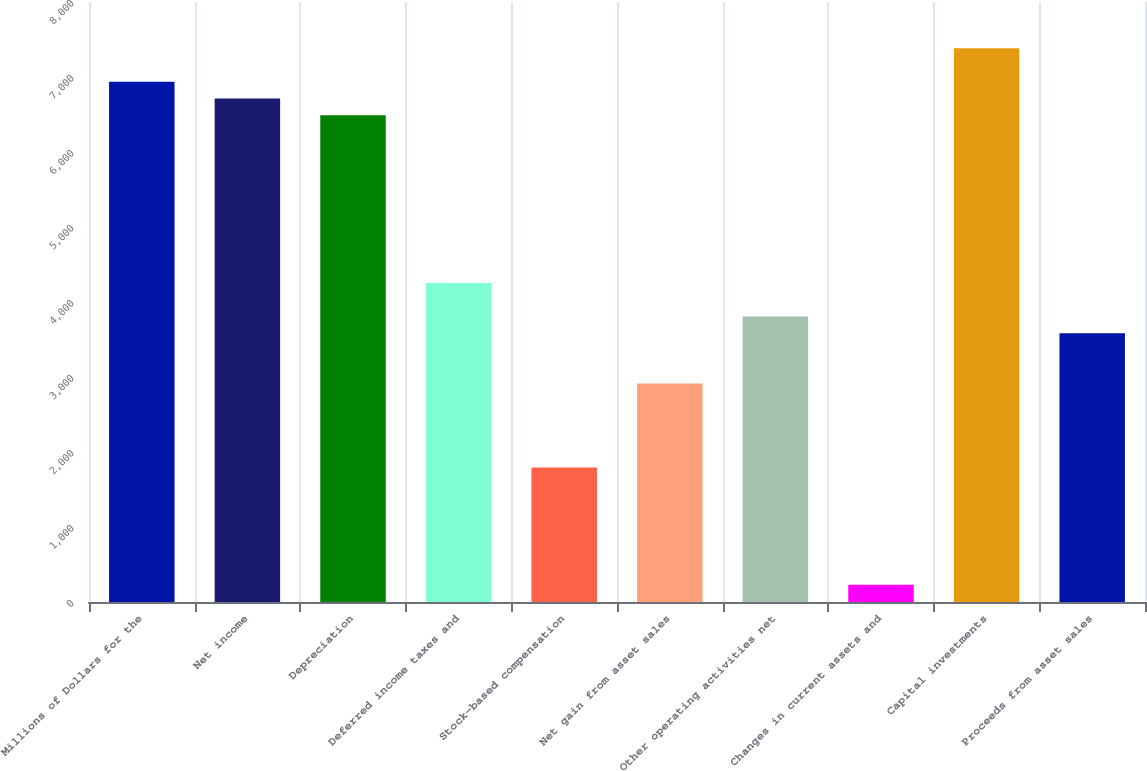<chart> <loc_0><loc_0><loc_500><loc_500><bar_chart><fcel>Millions of Dollars for the<fcel>Net income<fcel>Depreciation<fcel>Deferred income taxes and<fcel>Stock-based compensation<fcel>Net gain from asset sales<fcel>Other operating activities net<fcel>Changes in current assets and<fcel>Capital investments<fcel>Proceeds from asset sales<nl><fcel>6937.6<fcel>6714<fcel>6490.4<fcel>4254.4<fcel>1794.8<fcel>2912.8<fcel>3807.2<fcel>229.6<fcel>7384.8<fcel>3583.6<nl></chart> 